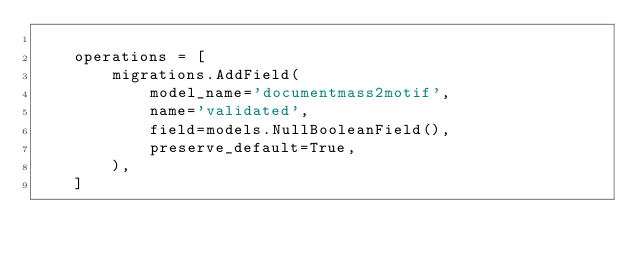Convert code to text. <code><loc_0><loc_0><loc_500><loc_500><_Python_>
    operations = [
        migrations.AddField(
            model_name='documentmass2motif',
            name='validated',
            field=models.NullBooleanField(),
            preserve_default=True,
        ),
    ]
</code> 